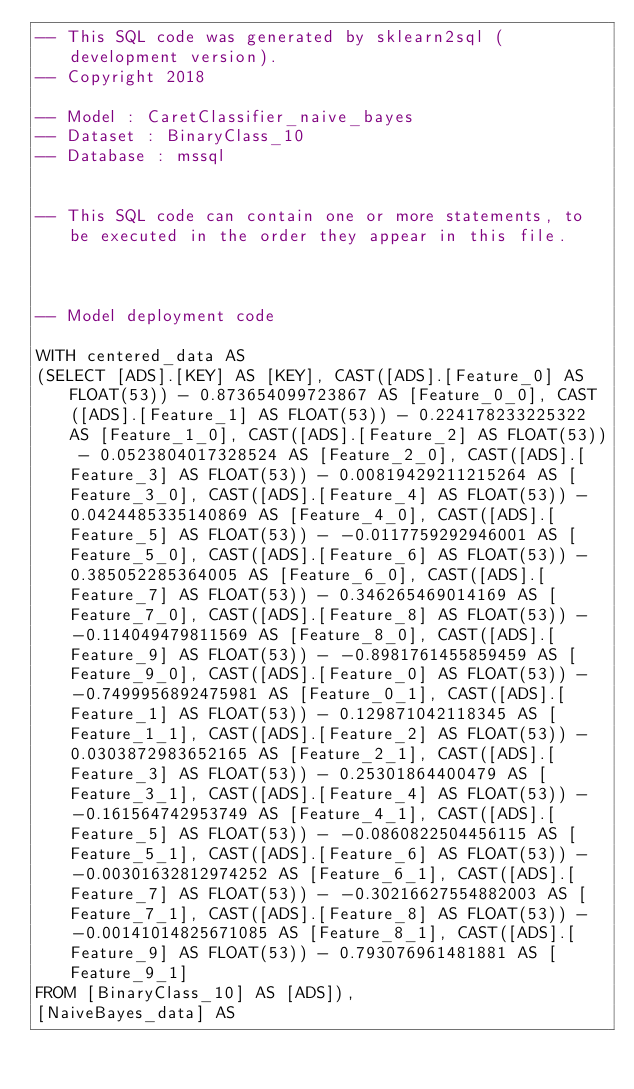<code> <loc_0><loc_0><loc_500><loc_500><_SQL_>-- This SQL code was generated by sklearn2sql (development version).
-- Copyright 2018

-- Model : CaretClassifier_naive_bayes
-- Dataset : BinaryClass_10
-- Database : mssql


-- This SQL code can contain one or more statements, to be executed in the order they appear in this file.



-- Model deployment code

WITH centered_data AS 
(SELECT [ADS].[KEY] AS [KEY], CAST([ADS].[Feature_0] AS FLOAT(53)) - 0.873654099723867 AS [Feature_0_0], CAST([ADS].[Feature_1] AS FLOAT(53)) - 0.224178233225322 AS [Feature_1_0], CAST([ADS].[Feature_2] AS FLOAT(53)) - 0.0523804017328524 AS [Feature_2_0], CAST([ADS].[Feature_3] AS FLOAT(53)) - 0.00819429211215264 AS [Feature_3_0], CAST([ADS].[Feature_4] AS FLOAT(53)) - 0.0424485335140869 AS [Feature_4_0], CAST([ADS].[Feature_5] AS FLOAT(53)) - -0.0117759292946001 AS [Feature_5_0], CAST([ADS].[Feature_6] AS FLOAT(53)) - 0.385052285364005 AS [Feature_6_0], CAST([ADS].[Feature_7] AS FLOAT(53)) - 0.346265469014169 AS [Feature_7_0], CAST([ADS].[Feature_8] AS FLOAT(53)) - -0.114049479811569 AS [Feature_8_0], CAST([ADS].[Feature_9] AS FLOAT(53)) - -0.8981761455859459 AS [Feature_9_0], CAST([ADS].[Feature_0] AS FLOAT(53)) - -0.7499956892475981 AS [Feature_0_1], CAST([ADS].[Feature_1] AS FLOAT(53)) - 0.129871042118345 AS [Feature_1_1], CAST([ADS].[Feature_2] AS FLOAT(53)) - 0.0303872983652165 AS [Feature_2_1], CAST([ADS].[Feature_3] AS FLOAT(53)) - 0.25301864400479 AS [Feature_3_1], CAST([ADS].[Feature_4] AS FLOAT(53)) - -0.161564742953749 AS [Feature_4_1], CAST([ADS].[Feature_5] AS FLOAT(53)) - -0.0860822504456115 AS [Feature_5_1], CAST([ADS].[Feature_6] AS FLOAT(53)) - -0.00301632812974252 AS [Feature_6_1], CAST([ADS].[Feature_7] AS FLOAT(53)) - -0.30216627554882003 AS [Feature_7_1], CAST([ADS].[Feature_8] AS FLOAT(53)) - -0.00141014825671085 AS [Feature_8_1], CAST([ADS].[Feature_9] AS FLOAT(53)) - 0.793076961481881 AS [Feature_9_1] 
FROM [BinaryClass_10] AS [ADS]), 
[NaiveBayes_data] AS </code> 